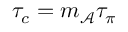Convert formula to latex. <formula><loc_0><loc_0><loc_500><loc_500>\tau _ { c } = m _ { \mathcal { A } } \tau _ { \pi }</formula> 